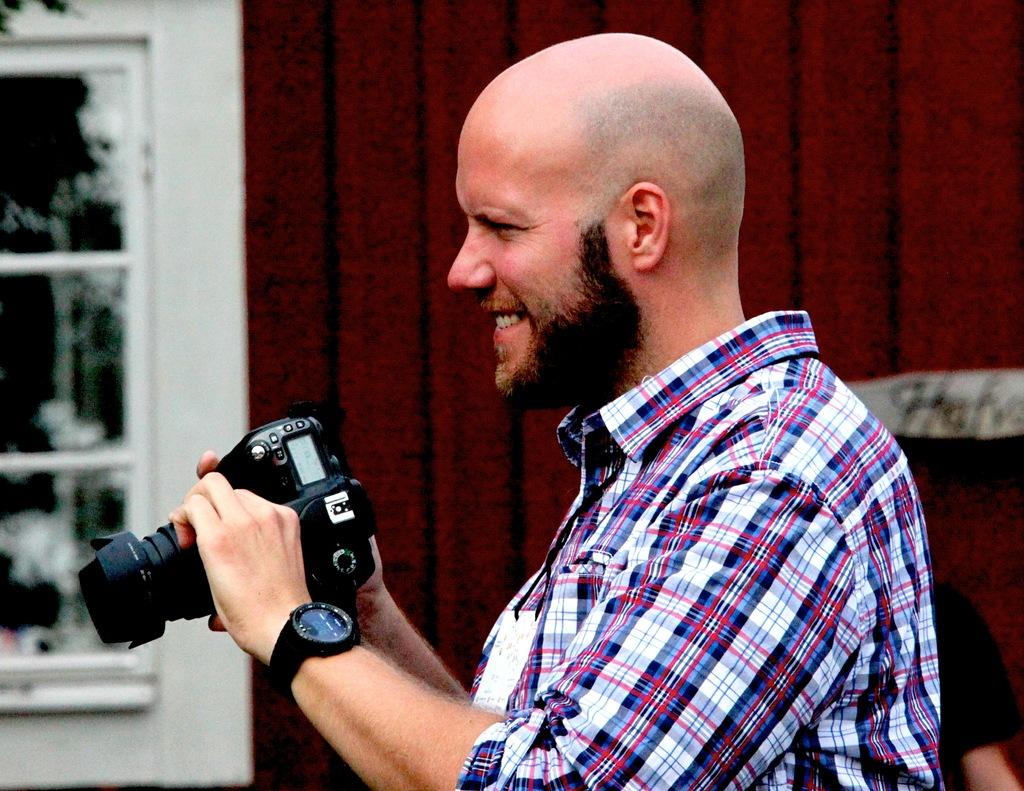Who is the main subject in the image? There is a man in the image. What is the man doing in the image? The man is standing and holding a camera in his hands. What is the man's facial expression in the image? The man is smiling in the image. What is the man wearing in the image? The man is wearing a shirt in the image. How many passengers are visible in the image? There are no passengers visible in the image; it features a man holding a camera. 